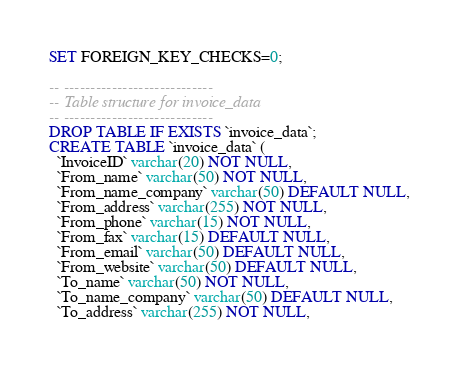Convert code to text. <code><loc_0><loc_0><loc_500><loc_500><_SQL_>SET FOREIGN_KEY_CHECKS=0;

-- ----------------------------
-- Table structure for invoice_data
-- ----------------------------
DROP TABLE IF EXISTS `invoice_data`;
CREATE TABLE `invoice_data` (
  `InvoiceID` varchar(20) NOT NULL,
  `From_name` varchar(50) NOT NULL,
  `From_name_company` varchar(50) DEFAULT NULL,
  `From_address` varchar(255) NOT NULL,
  `From_phone` varchar(15) NOT NULL,
  `From_fax` varchar(15) DEFAULT NULL,
  `From_email` varchar(50) DEFAULT NULL,
  `From_website` varchar(50) DEFAULT NULL,
  `To_name` varchar(50) NOT NULL,
  `To_name_company` varchar(50) DEFAULT NULL,
  `To_address` varchar(255) NOT NULL,</code> 